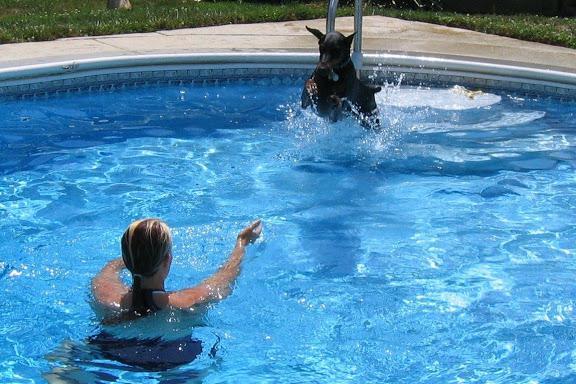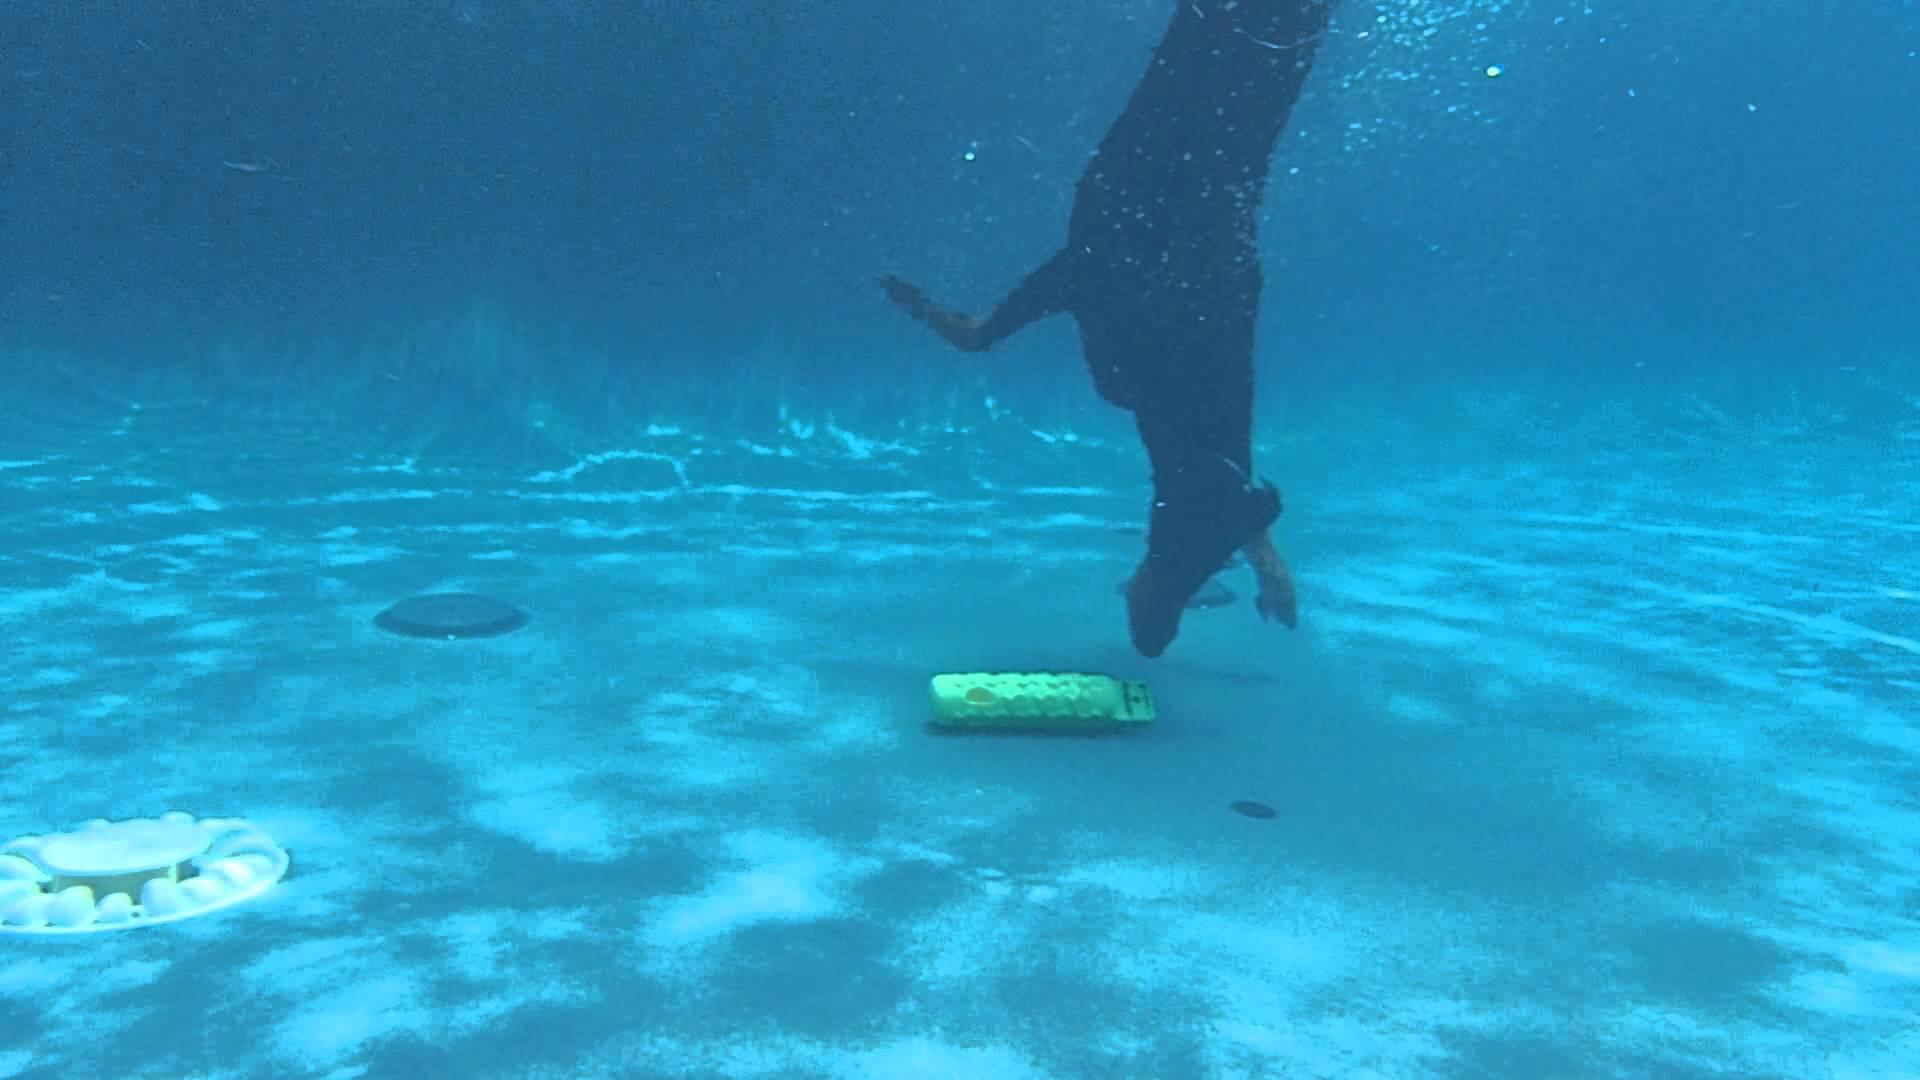The first image is the image on the left, the second image is the image on the right. Given the left and right images, does the statement "An image shows a doberman underwater with his muzzle pointed downward just above a flat object." hold true? Answer yes or no. Yes. 